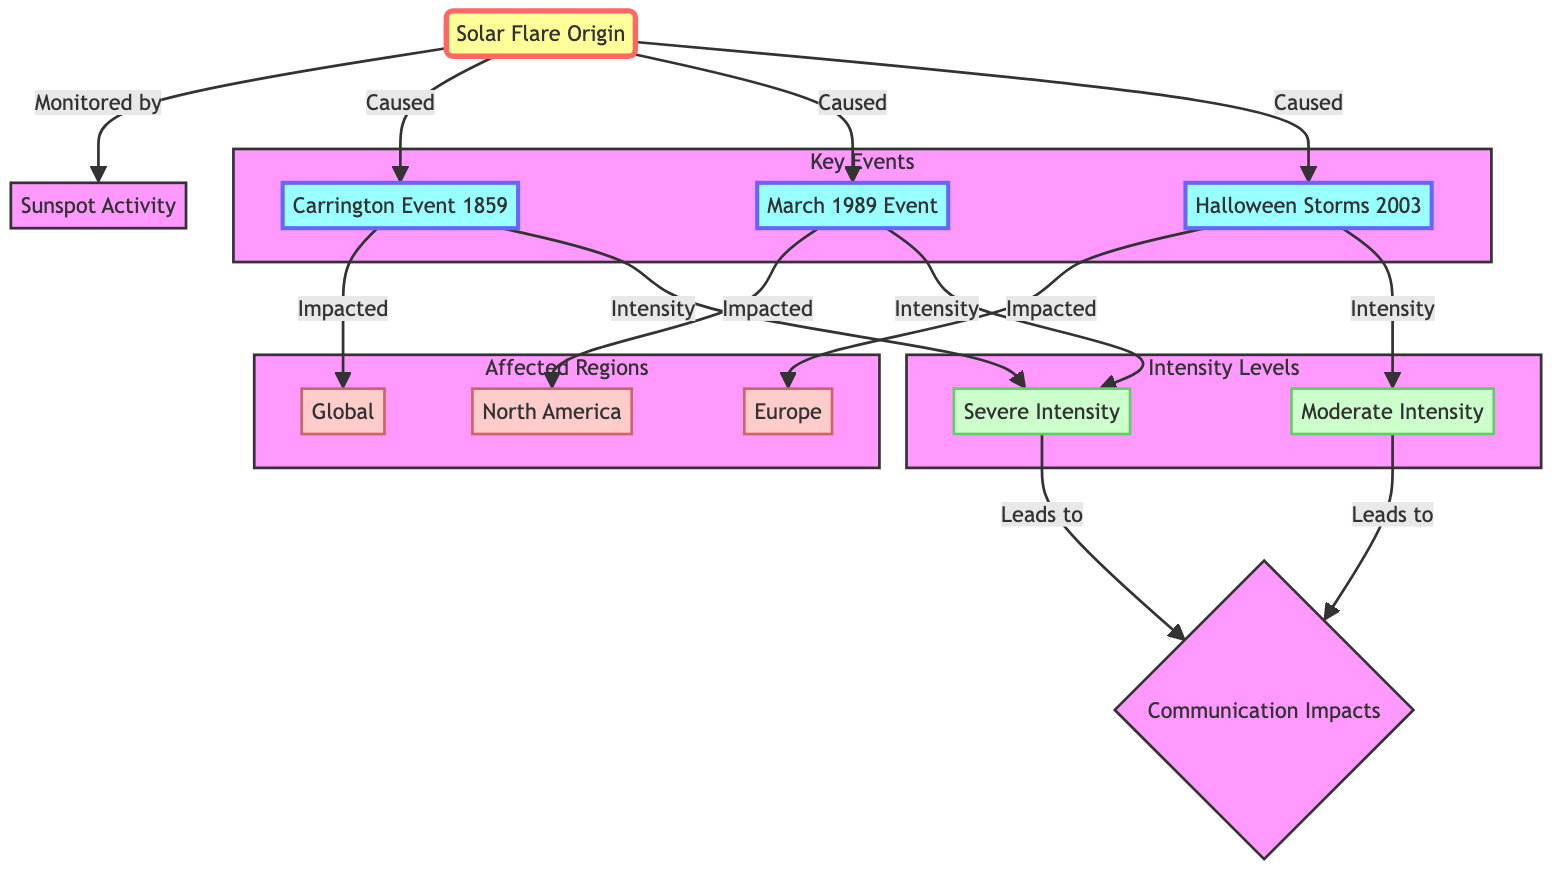What is the origin of the solar flares depicted in the diagram? The diagram identifies "SFO" as the Solar Flare Origin. This node is connected to the sunspot activity and the events caused by the solar flare.
Answer: Solar Flare Origin How many key events are represented in the diagram? The diagram includes three key events: Carrington Event 1859, March 1989 Event, and Halloween Storms 2003. These events are grouped under the subgraph 'Key Events'.
Answer: 3 Which region is impacted by the March 1989 Event? The March 1989 Event is directly connected to North America in the diagram. This relationship indicates that North America is affected by this particular solar flare event.
Answer: North America What is the intensity level of the Carrington Event 1859 and March 1989 Event combined? Both the Carrington Event and the March 1989 Event indicate a connection to Severe Intensity in the diagram, suggesting that they have this level of impact on communication systems.
Answer: Severe Intensity Which intensity level does the Halloween Storms 2003 event correspond to? The Halloween Storms 2003 event is linked in the diagram to Moderate Intensity. This connection indicates the specific impact level associated with this event.
Answer: Moderate Intensity How many regions are affected by the key events mentioned in the diagram? The diagram lists three regions: North America, Europe, and Global, which are interconnected to various key events. Thus, the total number of affected regions is three.
Answer: 3 Which event is associated with Europe in terms of communication impacts? The diagram shows that the Halloween Storms 2003 event is the one that impacts Europe, highlighting the relationship between this specific event and the communication issues faced in that region.
Answer: Halloween Storms 2003 What relationship exists between solar flares and communication impacts? The diagram indicates that all key events lead to communication impacts, implying that solar flares play a direct role in affecting these systems based on their intensity.
Answer: Leads to What type of diagram is illustrated here? The diagram is a flowchart, specifically designed to show relationships among solar flares, key events, affected regions, and intensity levels, characterized by radiating lines and zones.
Answer: Flowchart 